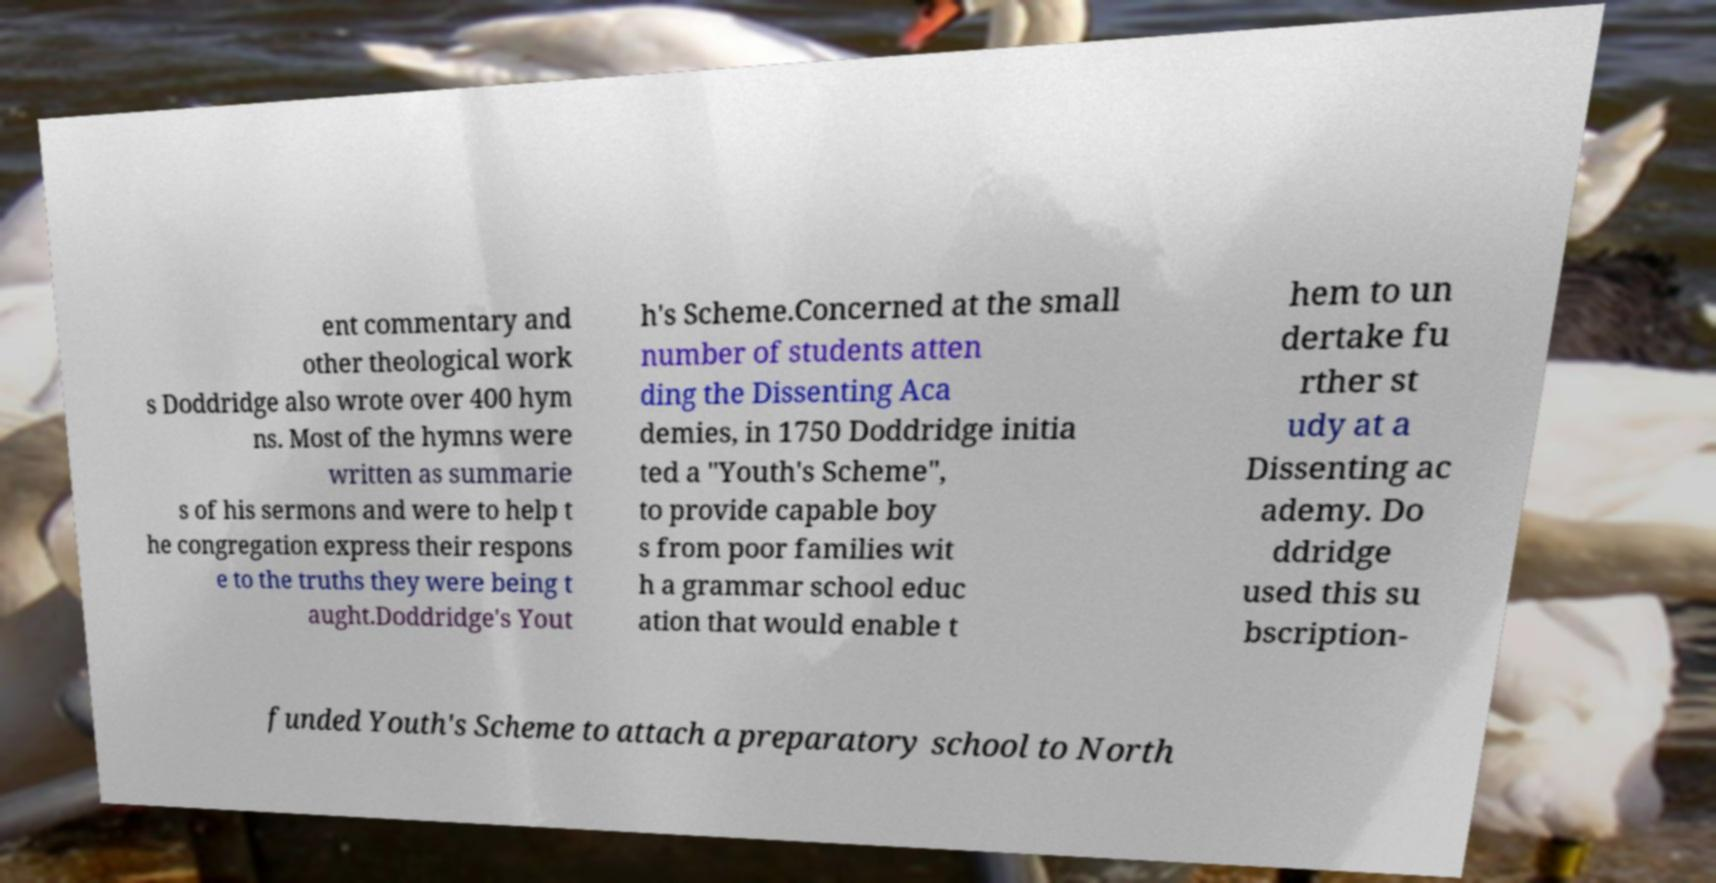What messages or text are displayed in this image? I need them in a readable, typed format. ent commentary and other theological work s Doddridge also wrote over 400 hym ns. Most of the hymns were written as summarie s of his sermons and were to help t he congregation express their respons e to the truths they were being t aught.Doddridge's Yout h's Scheme.Concerned at the small number of students atten ding the Dissenting Aca demies, in 1750 Doddridge initia ted a "Youth's Scheme", to provide capable boy s from poor families wit h a grammar school educ ation that would enable t hem to un dertake fu rther st udy at a Dissenting ac ademy. Do ddridge used this su bscription- funded Youth's Scheme to attach a preparatory school to North 